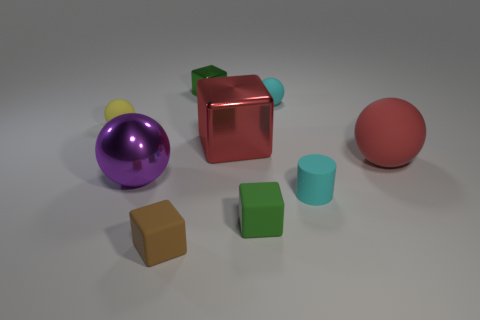Subtract all large shiny balls. How many balls are left? 3 Add 1 red cubes. How many objects exist? 10 Subtract all red cylinders. How many green cubes are left? 2 Subtract all yellow spheres. How many spheres are left? 3 Subtract 2 balls. How many balls are left? 2 Add 1 large things. How many large things are left? 4 Add 9 small red matte spheres. How many small red matte spheres exist? 9 Subtract 1 red cubes. How many objects are left? 8 Subtract all cylinders. How many objects are left? 8 Subtract all yellow cubes. Subtract all blue balls. How many cubes are left? 4 